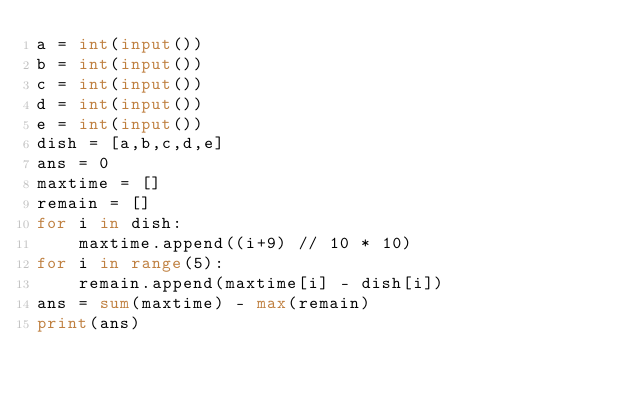Convert code to text. <code><loc_0><loc_0><loc_500><loc_500><_Python_>a = int(input())
b = int(input())
c = int(input())
d = int(input())
e = int(input())
dish = [a,b,c,d,e]
ans = 0
maxtime = []
remain = []
for i in dish:
    maxtime.append((i+9) // 10 * 10)
for i in range(5):
    remain.append(maxtime[i] - dish[i])
ans = sum(maxtime) - max(remain)
print(ans)
</code> 